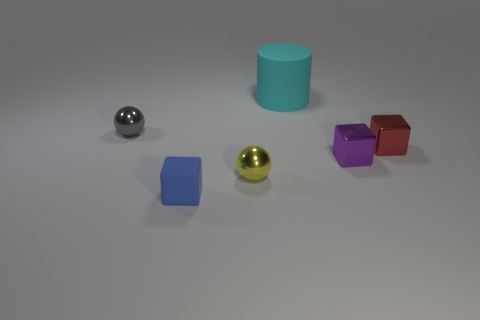How many things are either gray metal balls or shiny objects to the right of the small purple block?
Keep it short and to the point. 2. There is a matte object that is in front of the cyan matte cylinder; is its size the same as the shiny ball that is behind the yellow thing?
Keep it short and to the point. Yes. What number of tiny blue things have the same shape as the red object?
Offer a very short reply. 1. What is the shape of the small red object that is the same material as the tiny gray sphere?
Ensure brevity in your answer.  Cube. There is a cube that is on the left side of the shiny sphere that is on the right side of the rubber thing that is left of the large cyan cylinder; what is its material?
Give a very brief answer. Rubber. Do the blue matte thing and the metallic sphere behind the yellow shiny object have the same size?
Give a very brief answer. Yes. What is the material of the small blue object that is the same shape as the small purple thing?
Make the answer very short. Rubber. What size is the shiny sphere on the left side of the sphere that is in front of the shiny block that is behind the small purple block?
Offer a very short reply. Small. Do the gray ball and the cyan rubber thing have the same size?
Your response must be concise. No. What material is the tiny ball on the right side of the tiny cube that is left of the large object?
Provide a short and direct response. Metal. 